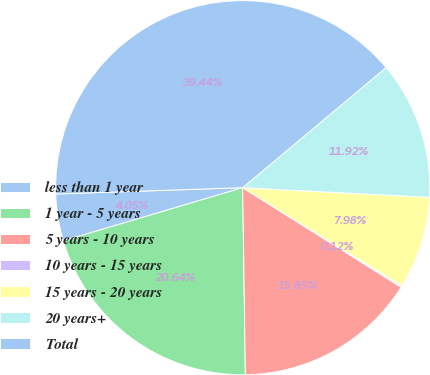Convert chart to OTSL. <chart><loc_0><loc_0><loc_500><loc_500><pie_chart><fcel>less than 1 year<fcel>1 year - 5 years<fcel>5 years - 10 years<fcel>10 years - 15 years<fcel>15 years - 20 years<fcel>20 years+<fcel>Total<nl><fcel>4.05%<fcel>20.64%<fcel>15.85%<fcel>0.12%<fcel>7.98%<fcel>11.92%<fcel>39.44%<nl></chart> 